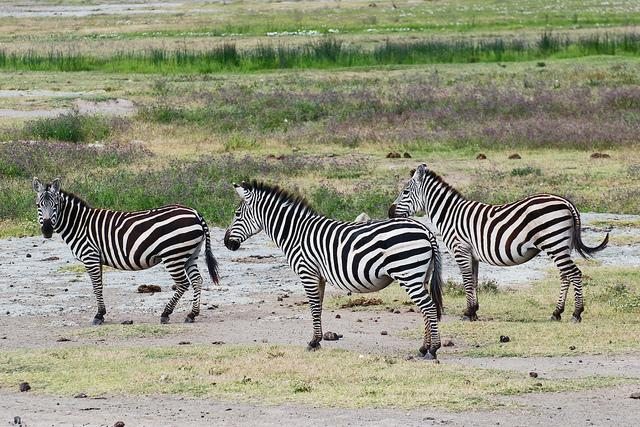What word shares the same first letter as the name of these animals? zoo 